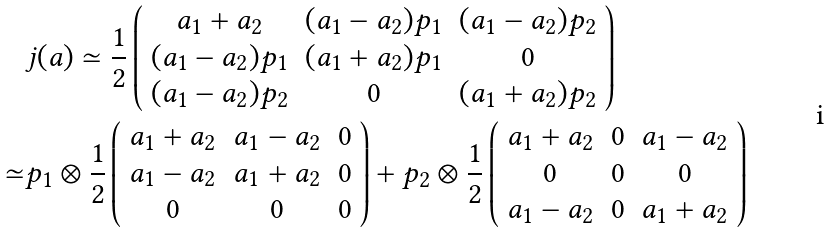Convert formula to latex. <formula><loc_0><loc_0><loc_500><loc_500>& j ( a ) \simeq \frac { 1 } { 2 } \left ( \begin{array} { c c c } a _ { 1 } + a _ { 2 } & ( a _ { 1 } - a _ { 2 } ) p _ { 1 } & ( a _ { 1 } - a _ { 2 } ) p _ { 2 } \\ ( a _ { 1 } - a _ { 2 } ) p _ { 1 } & ( a _ { 1 } + a _ { 2 } ) p _ { 1 } & 0 \\ ( a _ { 1 } - a _ { 2 } ) p _ { 2 } & 0 & ( a _ { 1 } + a _ { 2 } ) p _ { 2 } \\ \end{array} \right ) \\ \simeq & p _ { 1 } \otimes \frac { 1 } { 2 } \left ( \begin{array} { c c c } a _ { 1 } + a _ { 2 } & a _ { 1 } - a _ { 2 } & 0 \\ a _ { 1 } - a _ { 2 } & a _ { 1 } + a _ { 2 } & 0 \\ 0 & 0 & 0 \\ \end{array} \right ) + p _ { 2 } \otimes \frac { 1 } { 2 } \left ( \begin{array} { c c c } a _ { 1 } + a _ { 2 } & 0 & a _ { 1 } - a _ { 2 } \\ 0 & 0 & 0 \\ a _ { 1 } - a _ { 2 } & 0 & a _ { 1 } + a _ { 2 } \\ \end{array} \right )</formula> 